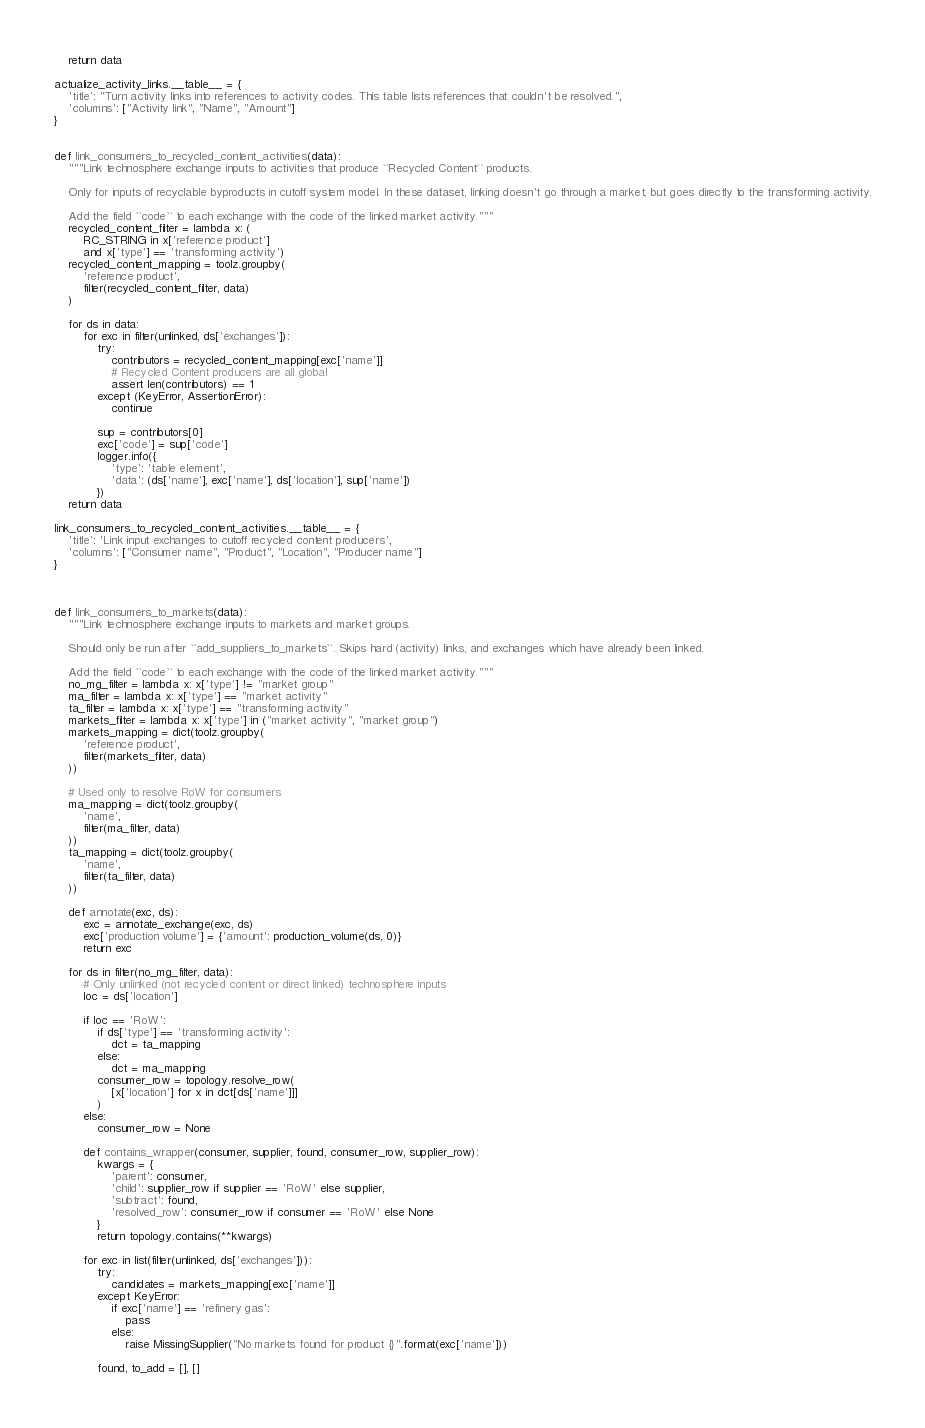<code> <loc_0><loc_0><loc_500><loc_500><_Python_>    return data

actualize_activity_links.__table__ = {
    'title': "Turn activity links into references to activity codes. This table lists references that couldn't be resolved.",
    'columns': ["Activity link", "Name", "Amount"]
}


def link_consumers_to_recycled_content_activities(data):
    """Link technosphere exchange inputs to activities that produce ``Recycled Content`` products.

    Only for inputs of recyclable byproducts in cutoff system model. In these dataset, linking doesn't go through a market, but goes directly to the transforming activity.

    Add the field ``code`` to each exchange with the code of the linked market activity."""
    recycled_content_filter = lambda x: (
        RC_STRING in x['reference product']
        and x['type'] == 'transforming activity')
    recycled_content_mapping = toolz.groupby(
        'reference product',
        filter(recycled_content_filter, data)
    )

    for ds in data:
        for exc in filter(unlinked, ds['exchanges']):
            try:
                contributors = recycled_content_mapping[exc['name']]
                # Recycled Content producers are all global
                assert len(contributors) == 1
            except (KeyError, AssertionError):
                continue

            sup = contributors[0]
            exc['code'] = sup['code']
            logger.info({
                'type': 'table element',
                'data': (ds['name'], exc['name'], ds['location'], sup['name'])
            })
    return data

link_consumers_to_recycled_content_activities.__table__ = {
    'title': 'Link input exchanges to cutoff recycled content producers',
    'columns': ["Consumer name", "Product", "Location", "Producer name"]
}



def link_consumers_to_markets(data):
    """Link technosphere exchange inputs to markets and market groups.

    Should only be run after ``add_suppliers_to_markets``. Skips hard (activity) links, and exchanges which have already been linked.

    Add the field ``code`` to each exchange with the code of the linked market activity."""
    no_mg_filter = lambda x: x['type'] != "market group"
    ma_filter = lambda x: x['type'] == "market activity"
    ta_filter = lambda x: x['type'] == "transforming activity"
    markets_filter = lambda x: x['type'] in ("market activity", "market group")
    markets_mapping = dict(toolz.groupby(
        'reference product',
        filter(markets_filter, data)
    ))

    # Used only to resolve RoW for consumers
    ma_mapping = dict(toolz.groupby(
        'name',
        filter(ma_filter, data)
    ))
    ta_mapping = dict(toolz.groupby(
        'name',
        filter(ta_filter, data)
    ))

    def annotate(exc, ds):
        exc = annotate_exchange(exc, ds)
        exc['production volume'] = {'amount': production_volume(ds, 0)}
        return exc

    for ds in filter(no_mg_filter, data):
        # Only unlinked (not recycled content or direct linked) technosphere inputs
        loc = ds['location']

        if loc == 'RoW':
            if ds['type'] == 'transforming activity':
                dct = ta_mapping
            else:
                dct = ma_mapping
            consumer_row = topology.resolve_row(
                [x['location'] for x in dct[ds['name']]]
            )
        else:
            consumer_row = None

        def contains_wrapper(consumer, supplier, found, consumer_row, supplier_row):
            kwargs = {
                'parent': consumer,
                'child': supplier_row if supplier == 'RoW' else supplier,
                'subtract': found,
                'resolved_row': consumer_row if consumer == 'RoW' else None
            }
            return topology.contains(**kwargs)

        for exc in list(filter(unlinked, ds['exchanges'])):
            try:
                candidates = markets_mapping[exc['name']]
            except KeyError:
                if exc['name'] == 'refinery gas':
                    pass
                else:
                    raise MissingSupplier("No markets found for product {}".format(exc['name']))

            found, to_add = [], []
</code> 